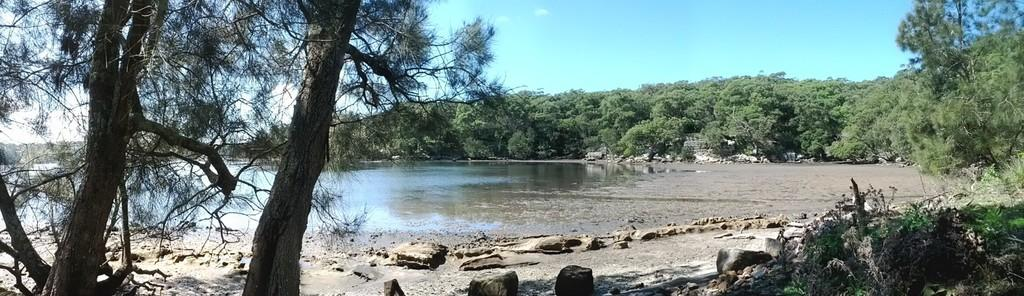What type of vegetation is present in the image? There are many trees in the image. What can be seen on the left side of the image? There is water visible on the left side of the image. What type of ground cover is present at the bottom of the image? Stones and grass are present at the bottom of the image. What is visible at the top of the image? The sky is visible at the top of the image. What can be seen in the sky in the image? Clouds are present in the sky. Where is the umbrella placed in the image? There is no umbrella present in the image. What type of rod is used to measure the depth of the water in the image? There is no rod or measurement of water depth in the image. 